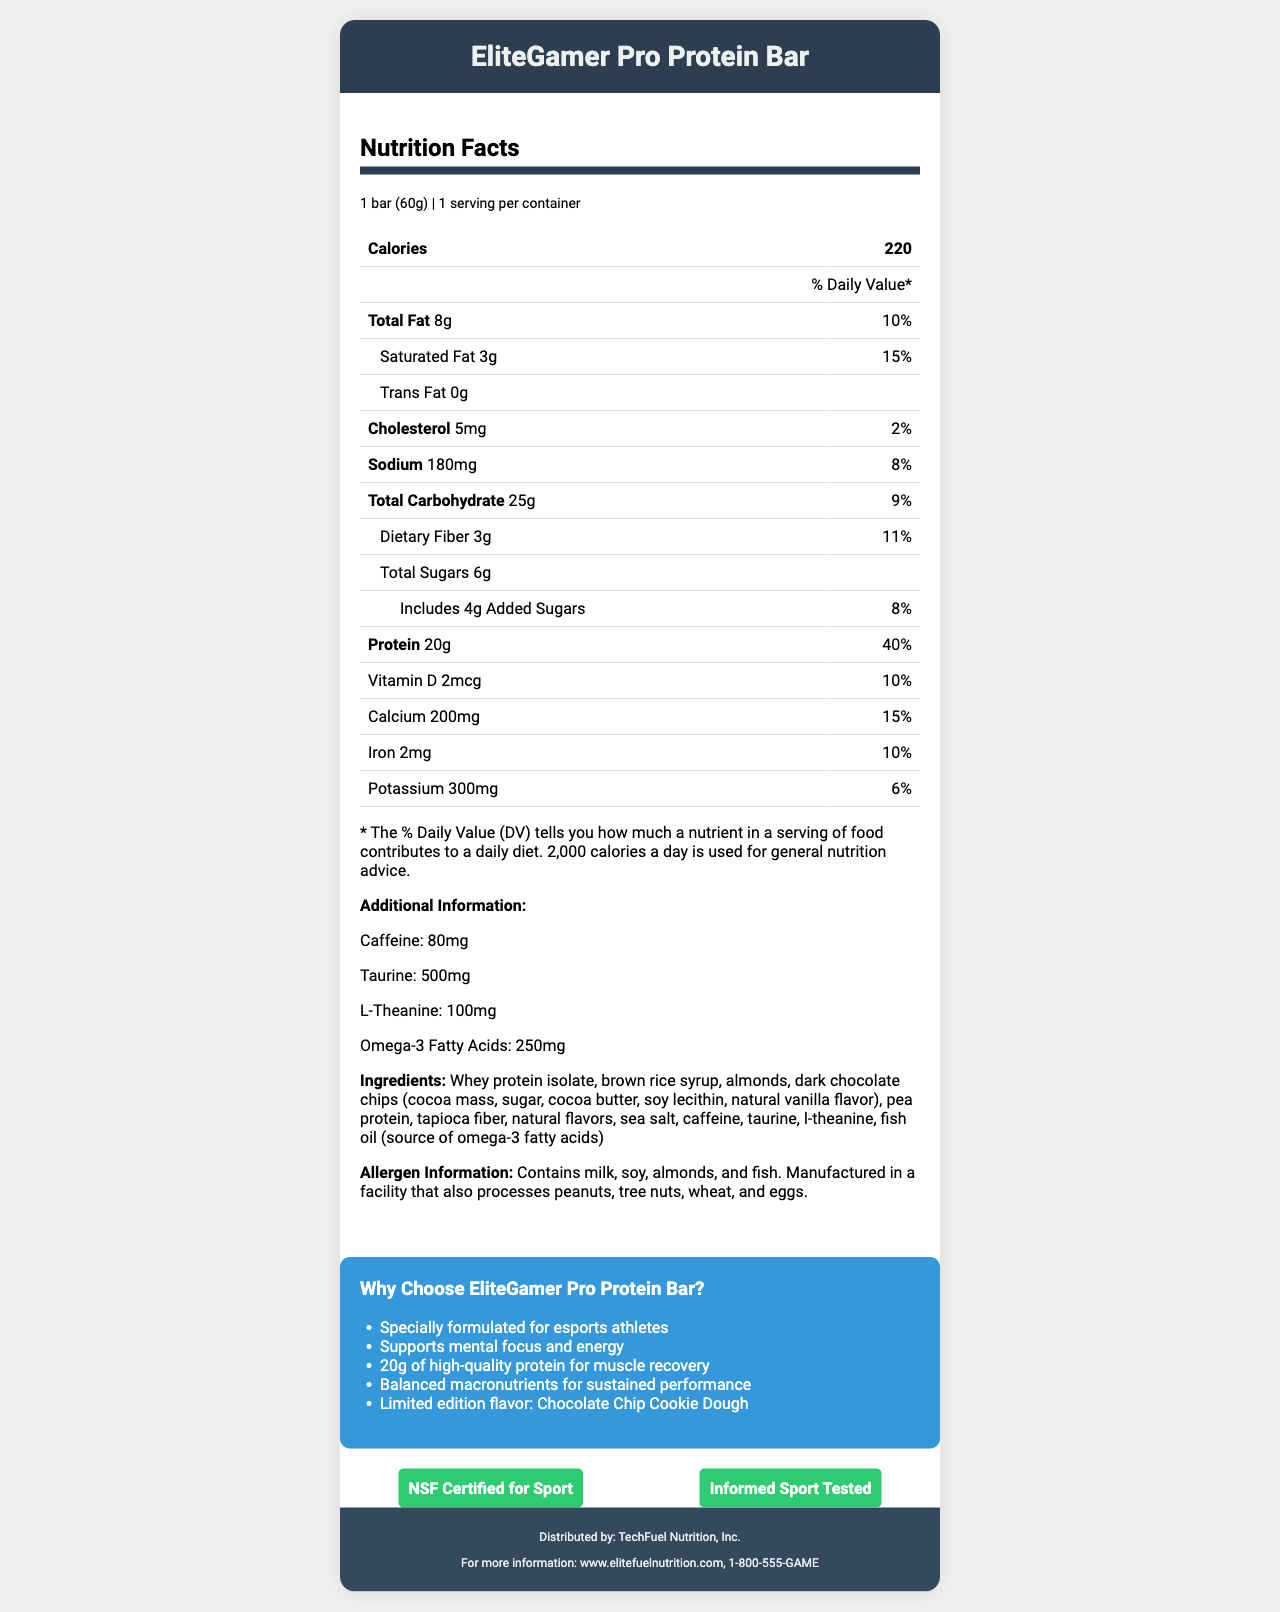what is the serving size of the EliteGamer Pro Protein Bar? The serving size is explicitly mentioned as "1 bar (60g)" in the nutrition facts section of the document.
Answer: 1 bar (60g) how many calories are in one serving of the EliteGamer Pro Protein Bar? The number of calories per serving is clearly stated as 220 in the nutrition facts.
Answer: 220 what is the total amount of fat in the EliteGamer Pro Protein Bar? The total amount of fat is listed as 8g in the nutrition facts section of the document.
Answer: 8g what is the daily value percentage for calcium in the EliteGamer Pro Protein Bar? The daily value percentage for calcium is stated as 15% in the nutrition facts section.
Answer: 15% which nutrient has the highest daily value percentage in the EliteGamer Pro Protein Bar? A. Total Fat B. Calcium C. Protein D. Iron The daily value percentage for protein is 40%, which is higher than that for total fat (10%), calcium (15%), and iron (10%).
Answer: C. Protein how much dietary fiber does the EliteGamer Pro Protein Bar contain? The amount of dietary fiber is listed as 3g in the nutrition facts.
Answer: 3g what type of fat is absent in the EliteGamer Pro Protein Bar? The document lists "Trans Fat 0g," indicating that the bar contains no trans fat.
Answer: Trans Fat which of the following certifications does the EliteGamer Pro Protein Bar have? A. USDA Organic B. NSF Certified for Sport C. Fair Trade D. Informed Choice Tested The certifications listed are "NSF Certified for Sport" and "Informed Sport Tested."
Answer: B. NSF Certified for Sport, D. Informed Sport Tested does the EliteGamer Pro Protein Bar contain caffeine? The document specifies that the bar contains 80mg of caffeine.
Answer: Yes who distributes the EliteGamer Pro Protein Bar? The distributor is listed as TechFuel Nutrition, Inc. in the footer section of the document.
Answer: TechFuel Nutrition, Inc. how many grams of added sugars are in the EliteGamer Pro Protein Bar? The document specifies that the bar includes 4g of added sugars.
Answer: 4g how much vitamin D does the EliteGamer Pro Protein Bar provide in micrograms? The amount of vitamin D is stated as 2mcg in the nutrition facts.
Answer: 2mcg summarize the main benefits of the EliteGamer Pro Protein Bar highlighted in the marketing claims. The marketing claims highlight that the bar is designed for esports athletes, enhances mental focus and energy, contains a significant amount of protein for muscle recovery, has balanced macronutrients for sustained performance, and comes in a unique flavor.
Answer: The EliteGamer Pro Protein Bar is specially formulated for esports athletes, supporting mental focus and energy with 20g of high-quality protein for muscle recovery and balanced macronutrients for sustained performance. It also features a limited edition Chocolate Chip Cookie Dough flavor. what is the source of omega-3 fatty acids in the EliteGamer Pro Protein Bar? The document specifies fish oil as the source of omega-3 fatty acids in the ingredients list.
Answer: Fish oil what is the contact information for TechFuel Nutrition, Inc.? The contact information is provided in the footer section of the document.
Answer: www.elitefuelnutrition.com, 1-800-555-GAME can you determine the price of the EliteGamer Pro Protein Bar from the information provided? The document does not provide any information regarding the price of the EliteGamer Pro Protein Bar.
Answer: Cannot be determined 